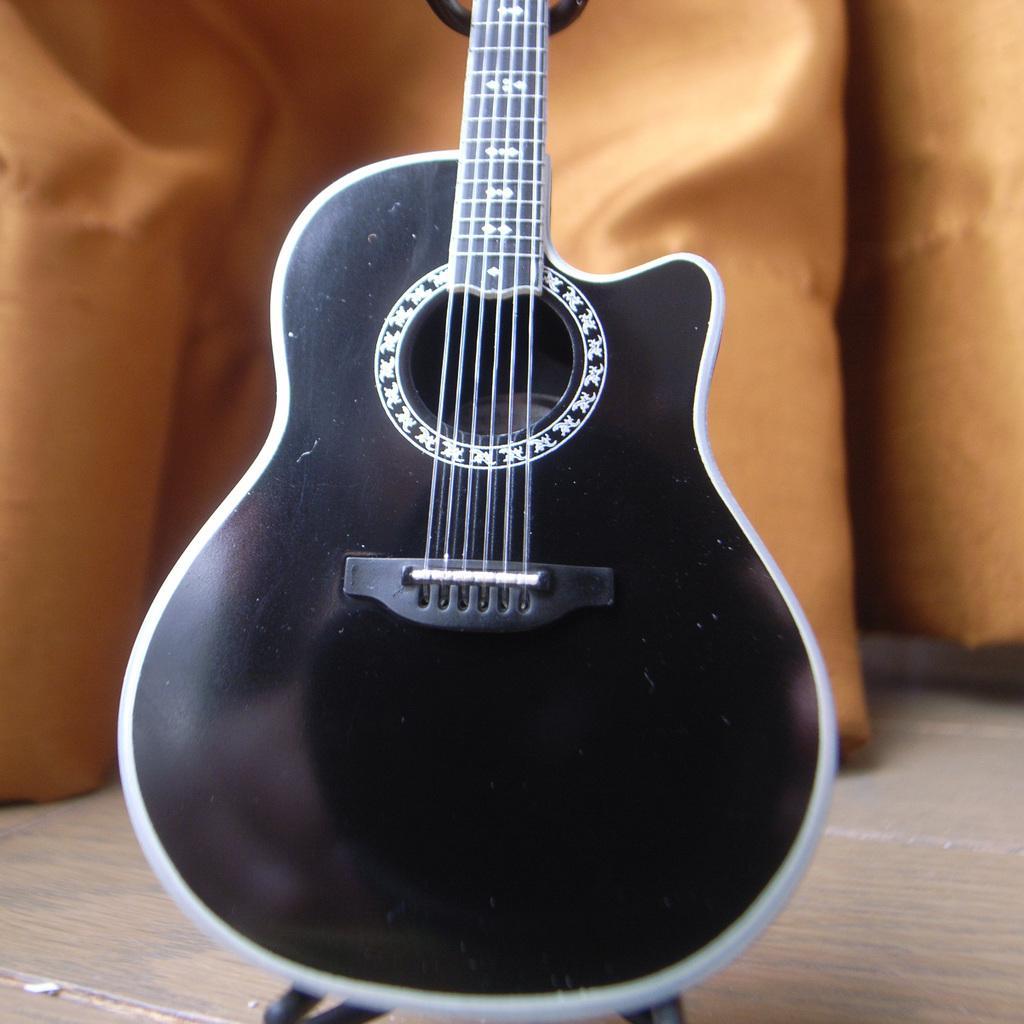How would you summarize this image in a sentence or two? In this picture I can see the black color guitar which is placed on the stand. In the back I can see the cloth. 